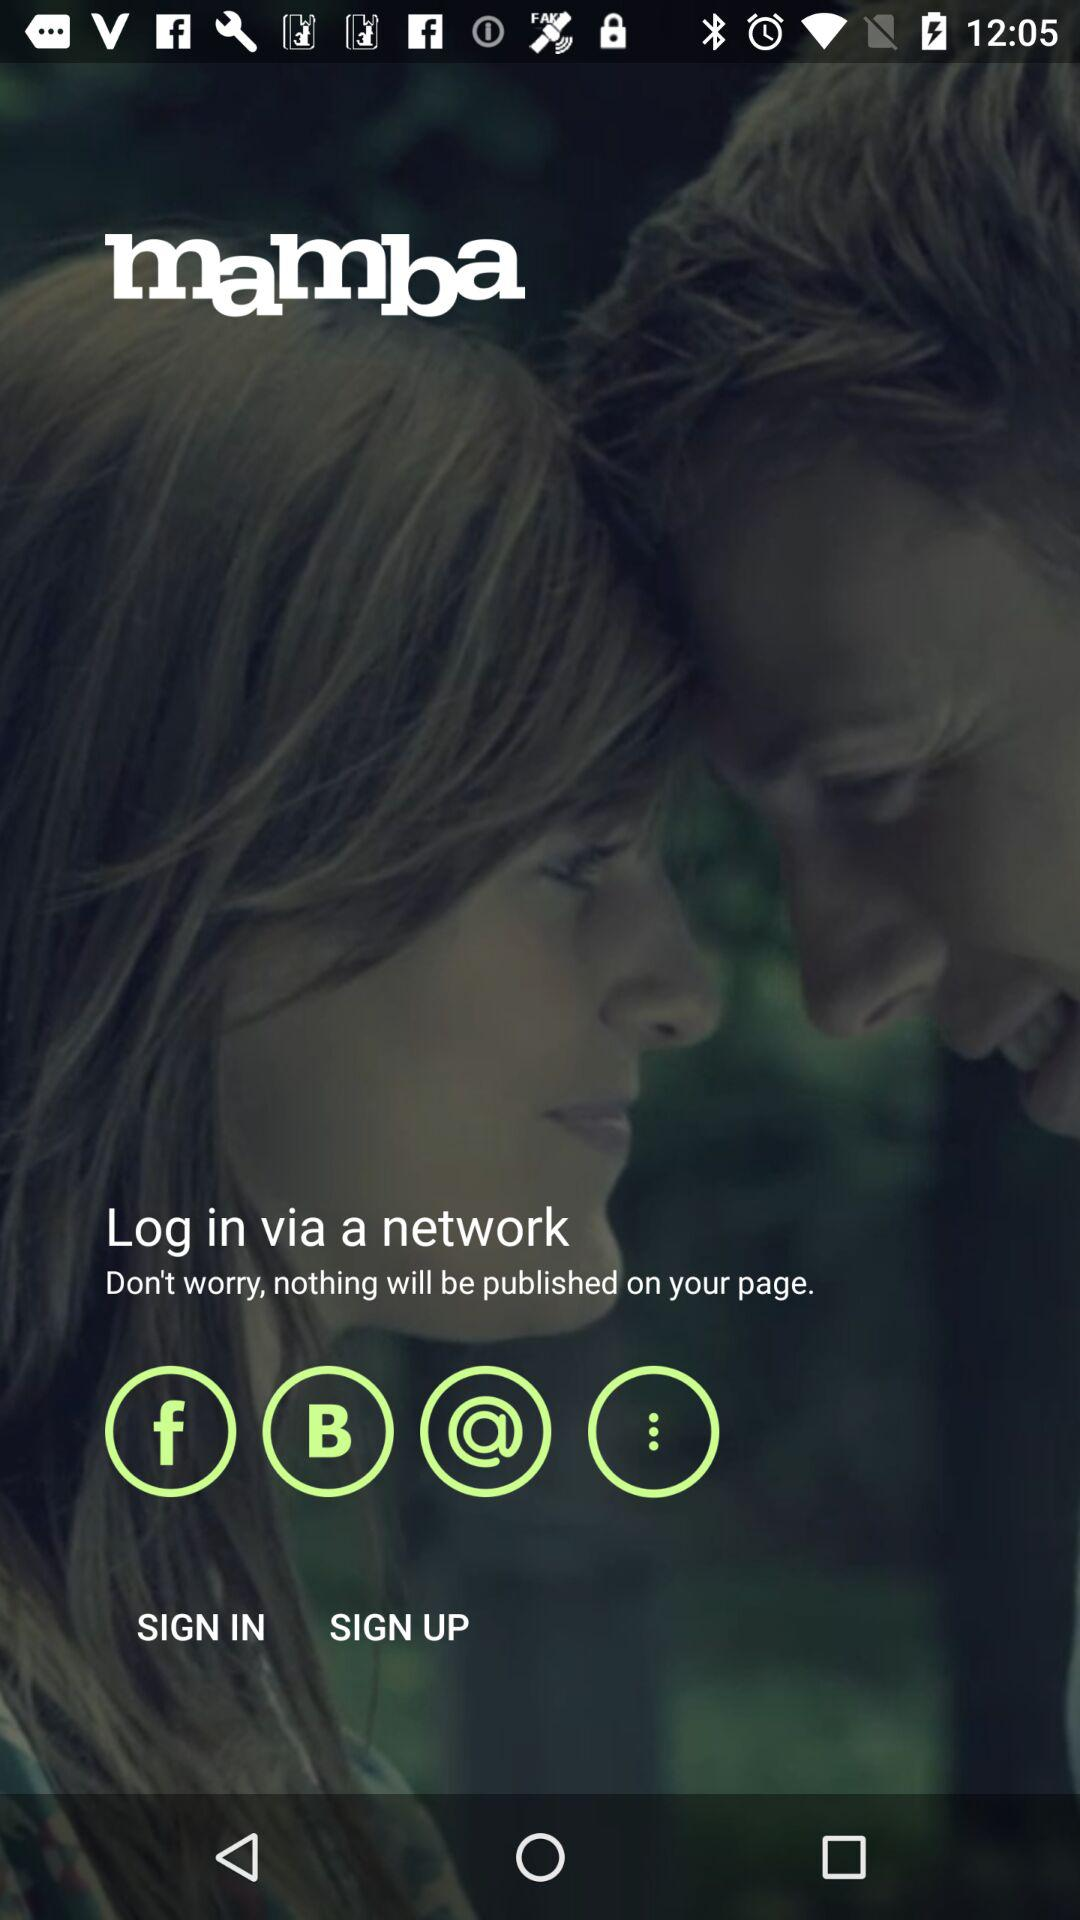When was the application last updated?
When the provided information is insufficient, respond with <no answer>. <no answer> 